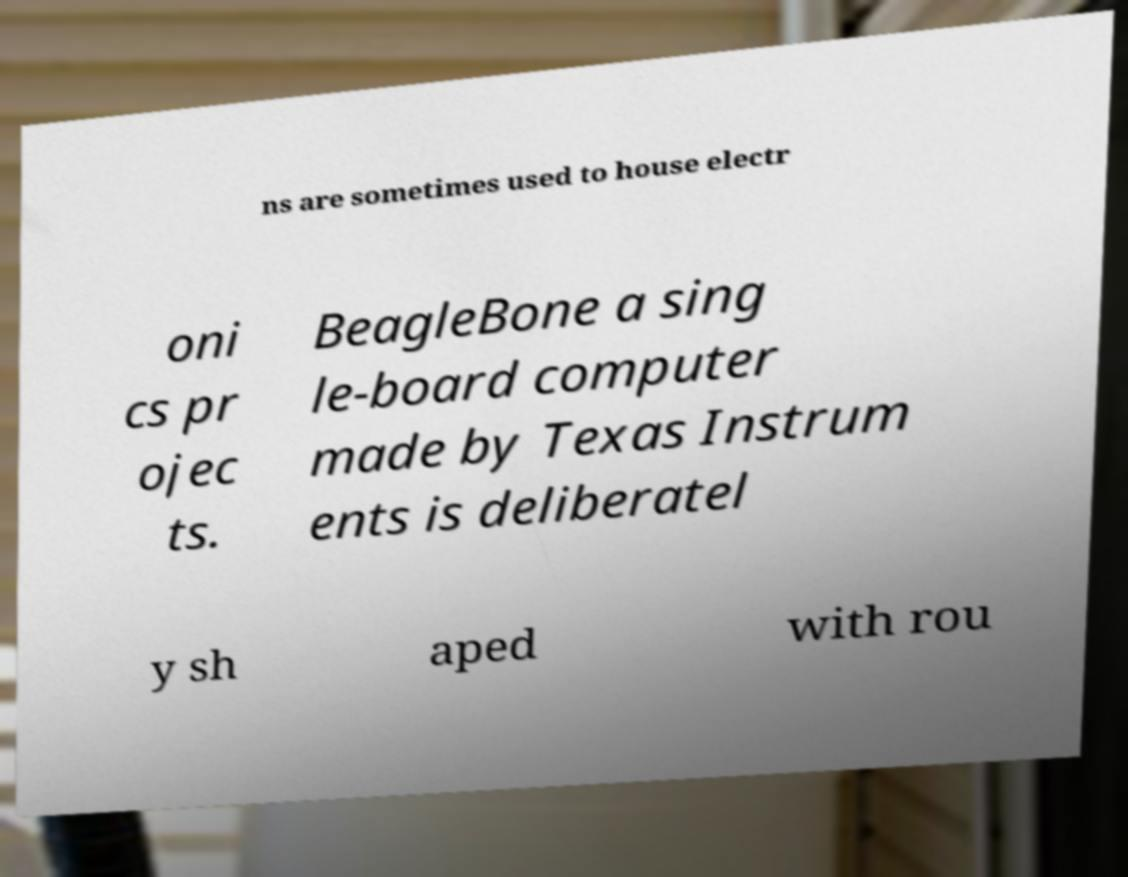Please identify and transcribe the text found in this image. ns are sometimes used to house electr oni cs pr ojec ts. BeagleBone a sing le-board computer made by Texas Instrum ents is deliberatel y sh aped with rou 